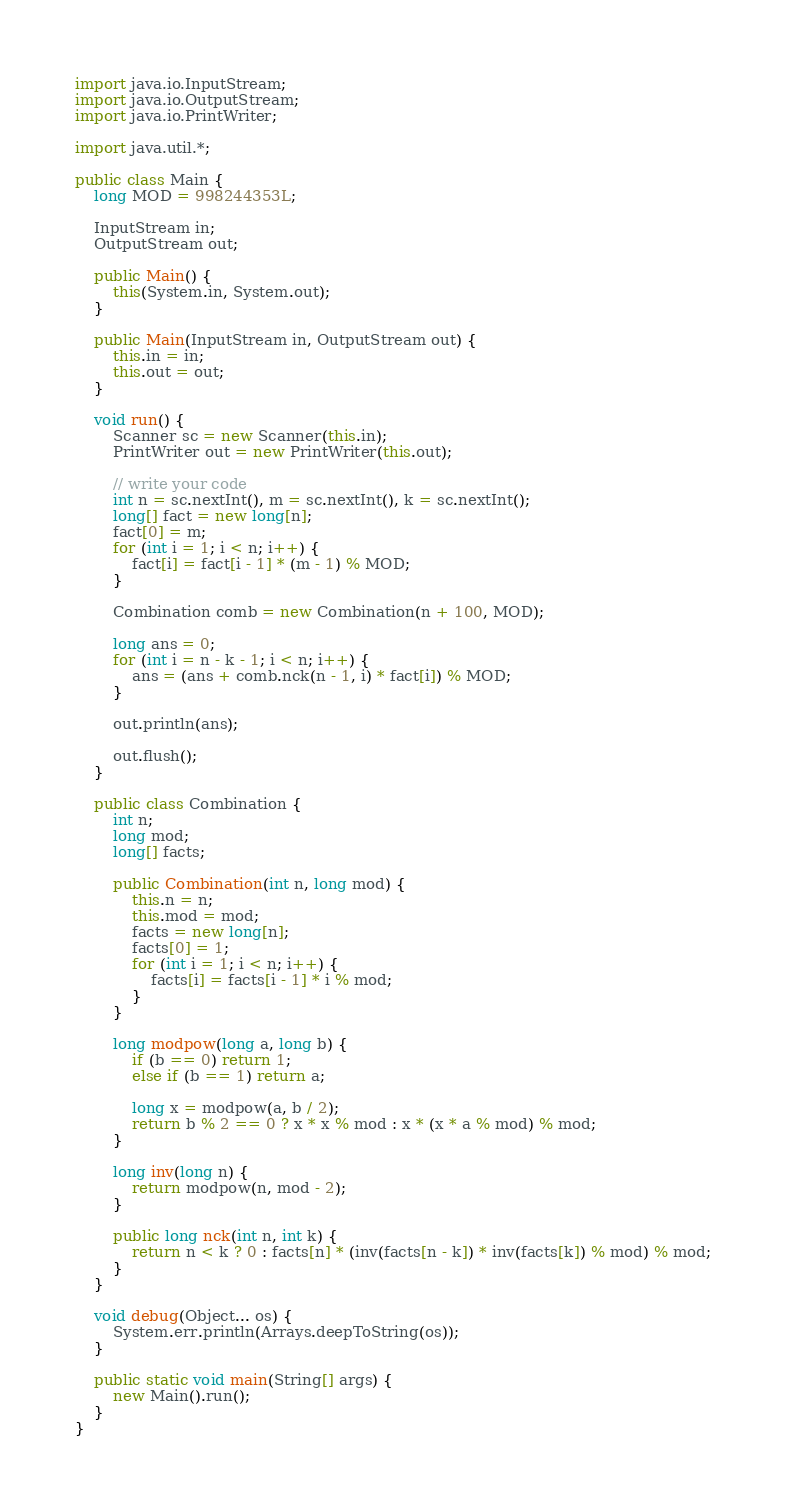<code> <loc_0><loc_0><loc_500><loc_500><_Java_>
import java.io.InputStream;
import java.io.OutputStream;
import java.io.PrintWriter;

import java.util.*;

public class Main {
    long MOD = 998244353L;

    InputStream in;
    OutputStream out;

    public Main() {
        this(System.in, System.out);
    }

    public Main(InputStream in, OutputStream out) {
        this.in = in;
        this.out = out;
    }

    void run() {
        Scanner sc = new Scanner(this.in);
        PrintWriter out = new PrintWriter(this.out);

        // write your code
        int n = sc.nextInt(), m = sc.nextInt(), k = sc.nextInt();
        long[] fact = new long[n];
        fact[0] = m;
        for (int i = 1; i < n; i++) {
            fact[i] = fact[i - 1] * (m - 1) % MOD;
        }

        Combination comb = new Combination(n + 100, MOD);

        long ans = 0;
        for (int i = n - k - 1; i < n; i++) {
            ans = (ans + comb.nck(n - 1, i) * fact[i]) % MOD;
        }

        out.println(ans);

        out.flush();
    }

    public class Combination {
        int n;
        long mod;
        long[] facts;

        public Combination(int n, long mod) {
            this.n = n;
            this.mod = mod;
            facts = new long[n];
            facts[0] = 1;
            for (int i = 1; i < n; i++) {
                facts[i] = facts[i - 1] * i % mod;
            }
        }

        long modpow(long a, long b) {
            if (b == 0) return 1;
            else if (b == 1) return a;

            long x = modpow(a, b / 2);
            return b % 2 == 0 ? x * x % mod : x * (x * a % mod) % mod;
        }

        long inv(long n) {
            return modpow(n, mod - 2);
        }

        public long nck(int n, int k) {
            return n < k ? 0 : facts[n] * (inv(facts[n - k]) * inv(facts[k]) % mod) % mod;
        }
    }

    void debug(Object... os) {
        System.err.println(Arrays.deepToString(os));
    }

    public static void main(String[] args) {
        new Main().run();
    }
}</code> 